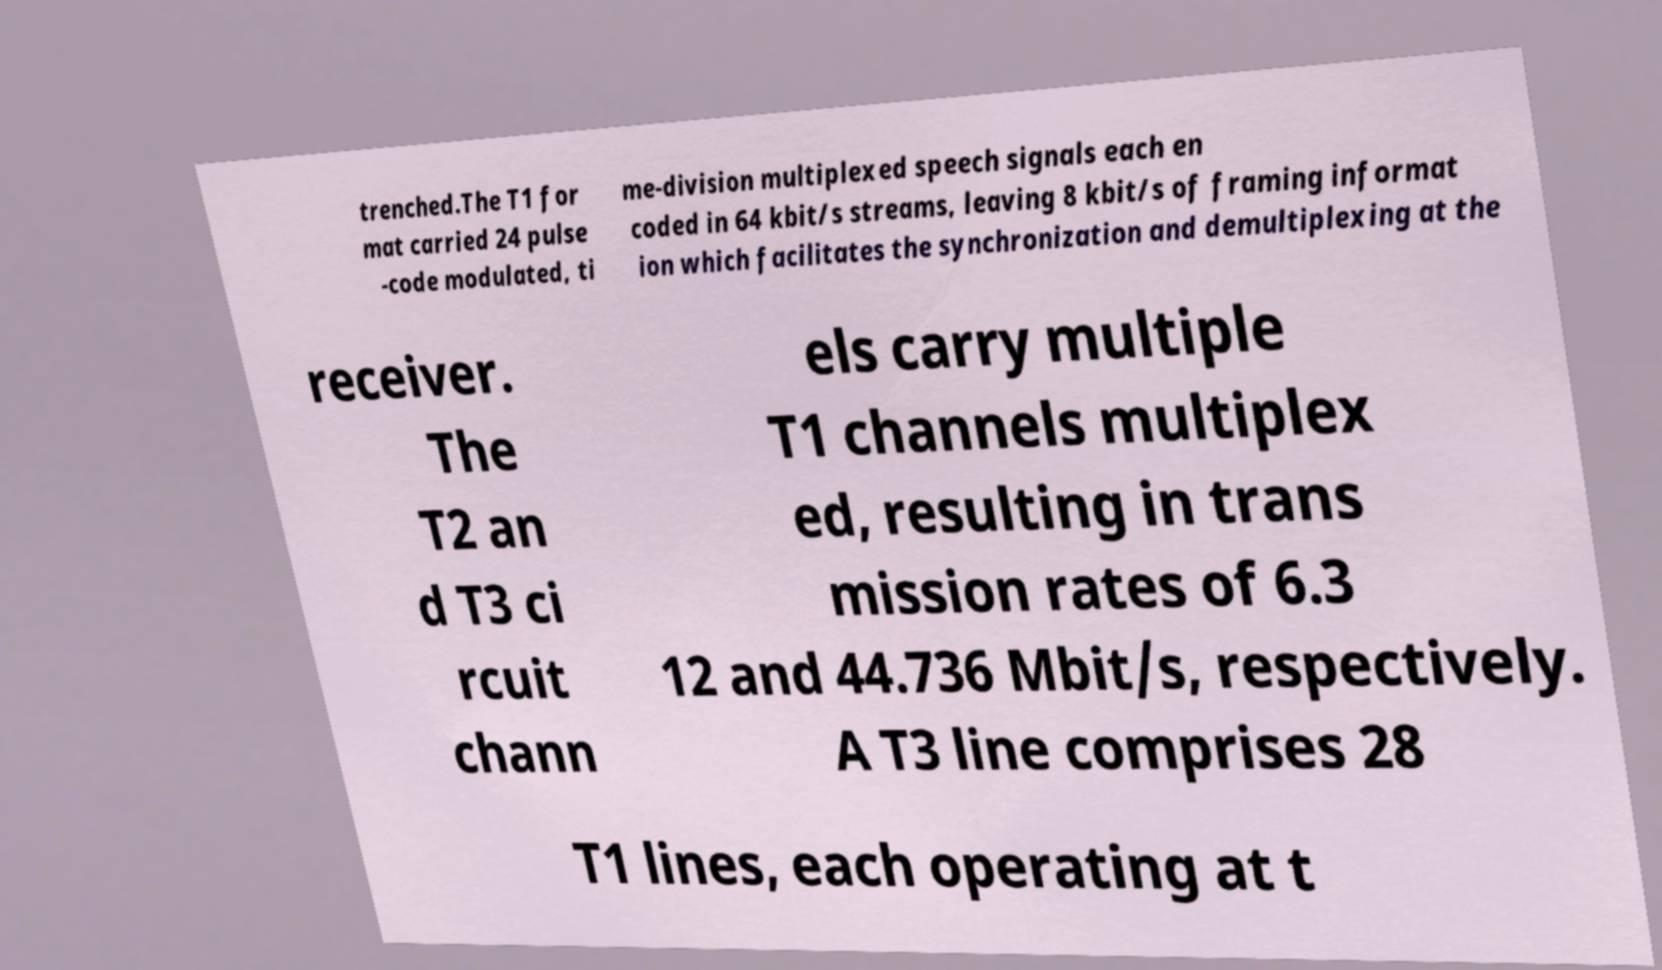Please read and relay the text visible in this image. What does it say? trenched.The T1 for mat carried 24 pulse -code modulated, ti me-division multiplexed speech signals each en coded in 64 kbit/s streams, leaving 8 kbit/s of framing informat ion which facilitates the synchronization and demultiplexing at the receiver. The T2 an d T3 ci rcuit chann els carry multiple T1 channels multiplex ed, resulting in trans mission rates of 6.3 12 and 44.736 Mbit/s, respectively. A T3 line comprises 28 T1 lines, each operating at t 